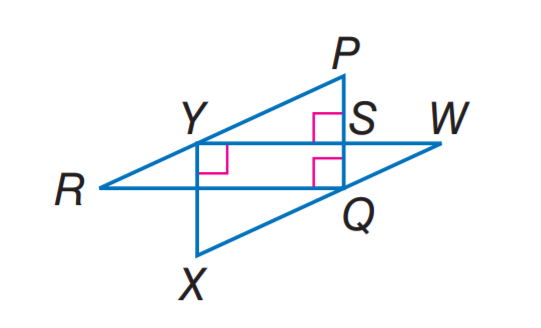Answer the mathemtical geometry problem and directly provide the correct option letter.
Question: If P R \parallel W X, W X = 10, X Y = 6, W Y = 8, R Y = 5, and P S = 3, find P Q.
Choices: A: 3 B: 4 C: 5 D: 6 D 